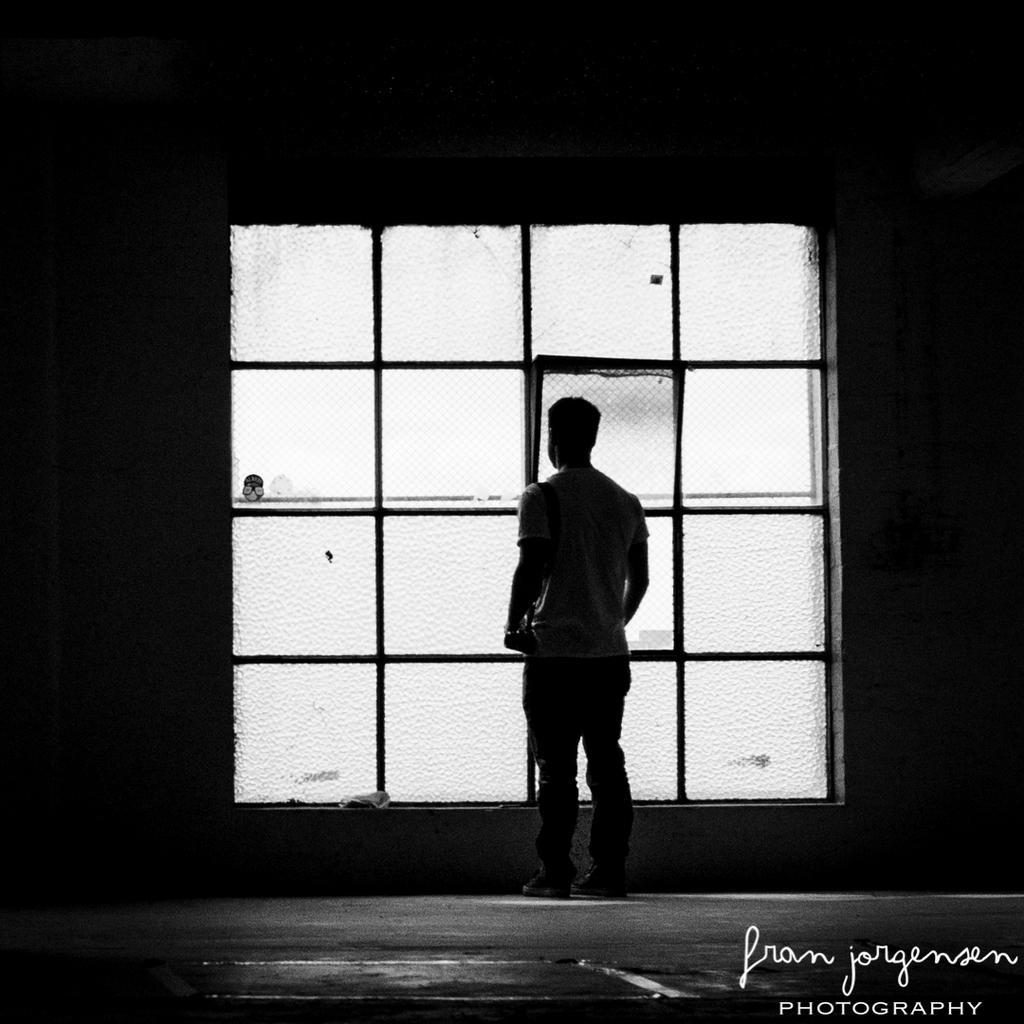In one or two sentences, can you explain what this image depicts? This is a black and white image. In the middle of the image there is a man standing facing towards the back side. In front of him there is a window. In the bottom right-hand corner there is some text. 